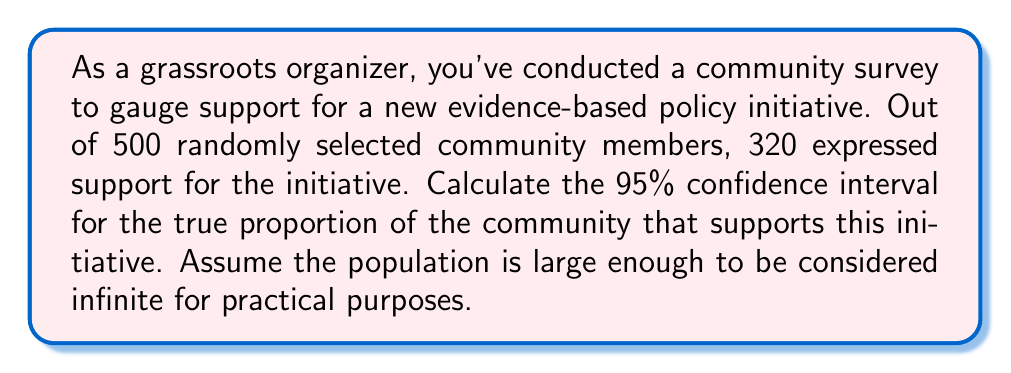Can you answer this question? To calculate the confidence interval, we'll use the formula for the margin of error in a proportion estimate:

$$\text{Margin of Error} = z \sqrt{\frac{p(1-p)}{n}}$$

Where:
$z$ is the z-score for the desired confidence level (1.96 for 95% confidence)
$p$ is the sample proportion
$n$ is the sample size

Step 1: Calculate the sample proportion $(p)$
$$p = \frac{320}{500} = 0.64$$

Step 2: Calculate the margin of error
$$\text{Margin of Error} = 1.96 \sqrt{\frac{0.64(1-0.64)}{500}}$$
$$= 1.96 \sqrt{\frac{0.64(0.36)}{500}}$$
$$= 1.96 \sqrt{0.0004608}$$
$$= 1.96 (0.02147)$$
$$= 0.04208$$

Step 3: Calculate the confidence interval
Lower bound: $0.64 - 0.04208 = 0.59792$
Upper bound: $0.64 + 0.04208 = 0.68208$

Therefore, we can say with 95% confidence that the true proportion of the community supporting the initiative is between 0.59792 and 0.68208, or approximately 59.8% to 68.2%.
Answer: The 95% confidence interval for the true proportion of the community supporting the initiative is (0.59792, 0.68208) or approximately (59.8%, 68.2%). 